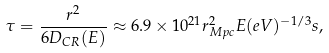<formula> <loc_0><loc_0><loc_500><loc_500>\tau = \frac { r ^ { 2 } } { 6 D _ { C R } ( E ) } \approx 6 . 9 \times 1 0 ^ { 2 1 } r _ { M p c } ^ { 2 } E ( e V ) ^ { - 1 / 3 } s ,</formula> 